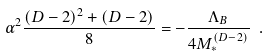<formula> <loc_0><loc_0><loc_500><loc_500>\alpha ^ { 2 } \frac { ( D - 2 ) ^ { 2 } + ( D - 2 ) } { 8 } = - \frac { \Lambda _ { B } } { 4 M _ { * } ^ { ( D - 2 ) } } \ .</formula> 